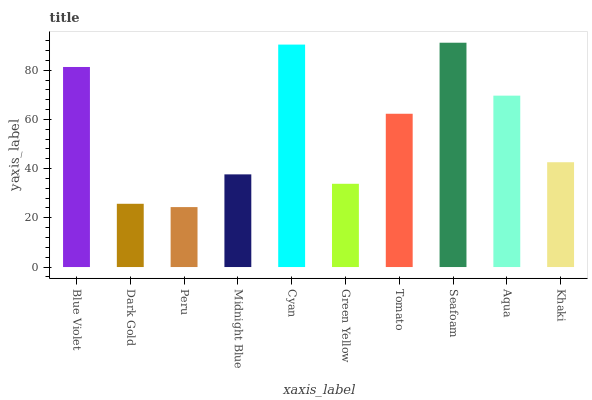Is Peru the minimum?
Answer yes or no. Yes. Is Seafoam the maximum?
Answer yes or no. Yes. Is Dark Gold the minimum?
Answer yes or no. No. Is Dark Gold the maximum?
Answer yes or no. No. Is Blue Violet greater than Dark Gold?
Answer yes or no. Yes. Is Dark Gold less than Blue Violet?
Answer yes or no. Yes. Is Dark Gold greater than Blue Violet?
Answer yes or no. No. Is Blue Violet less than Dark Gold?
Answer yes or no. No. Is Tomato the high median?
Answer yes or no. Yes. Is Khaki the low median?
Answer yes or no. Yes. Is Midnight Blue the high median?
Answer yes or no. No. Is Blue Violet the low median?
Answer yes or no. No. 